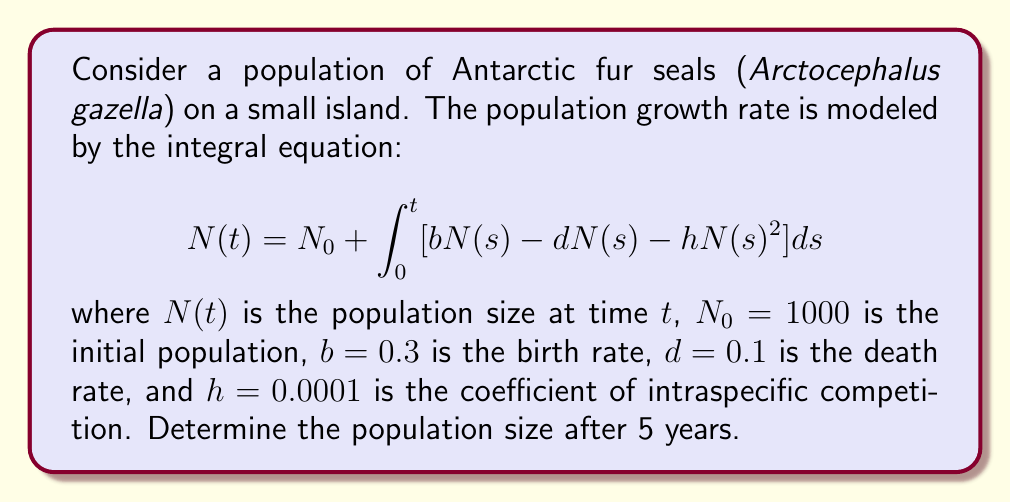Provide a solution to this math problem. To solve this integral equation, we'll use the following steps:

1) First, we need to recognize that this is a Volterra integral equation of the second kind. The solution can be approximated using numerical methods.

2) We'll use the Euler method to discretize the integral equation. Let's divide the time interval [0, 5] into 50 subintervals, each of length $\Delta t = 0.1$ years.

3) The discretized form of the equation is:

   $$N_{i+1} = N_i + \Delta t [bN_i - dN_i - hN_i^2]$$

4) We can simplify this to:

   $$N_{i+1} = N_i + 0.1 [0.3N_i - 0.1N_i - 0.0001N_i^2]$$
   $$N_{i+1} = N_i + 0.1 [0.2N_i - 0.0001N_i^2]$$

5) Now, let's iterate this equation 50 times, starting with $N_0 = 1000$:

   $N_1 = 1000 + 0.1 [0.2(1000) - 0.0001(1000)^2] = 1020$
   $N_2 = 1020 + 0.1 [0.2(1020) - 0.0001(1020)^2] = 1040.08$
   ...

6) Continuing this process (which would typically be done with a computer), we find that after 50 iterations (corresponding to 5 years):

   $N_{50} \approx 1834.62$

Therefore, the population size after 5 years is approximately 1835 fur seals.
Answer: 1835 fur seals 